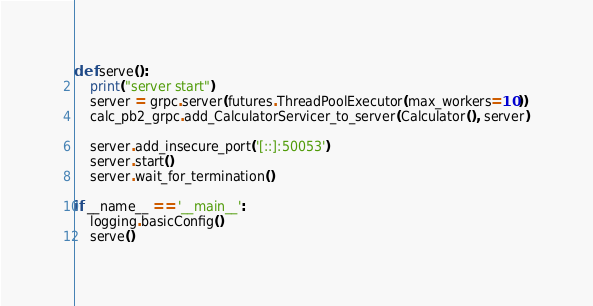Convert code to text. <code><loc_0><loc_0><loc_500><loc_500><_Python_>
def serve():
    print("server start")
    server = grpc.server(futures.ThreadPoolExecutor(max_workers=10))
    calc_pb2_grpc.add_CalculatorServicer_to_server(Calculator(), server)

    server.add_insecure_port('[::]:50053')
    server.start()
    server.wait_for_termination()

if __name__ == '__main__':
    logging.basicConfig()
    serve()
</code> 